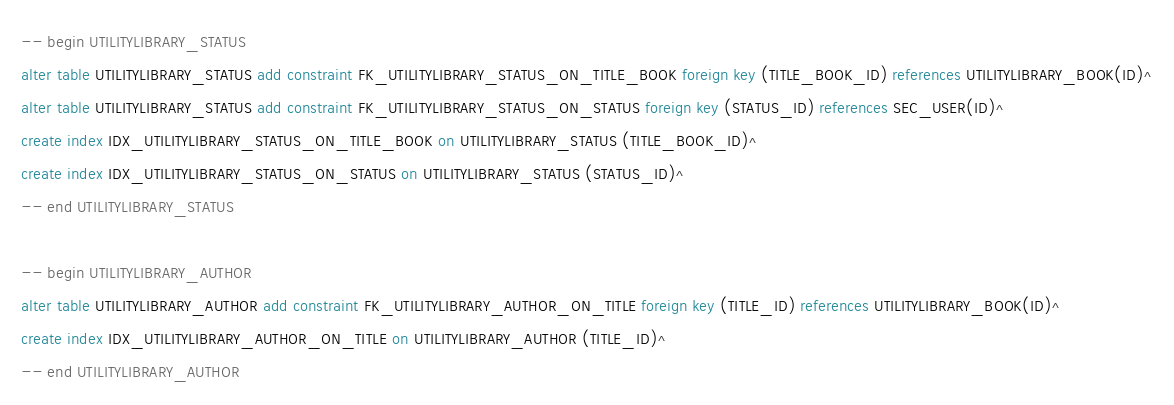Convert code to text. <code><loc_0><loc_0><loc_500><loc_500><_SQL_>-- begin UTILITYLIBRARY_STATUS
alter table UTILITYLIBRARY_STATUS add constraint FK_UTILITYLIBRARY_STATUS_ON_TITLE_BOOK foreign key (TITLE_BOOK_ID) references UTILITYLIBRARY_BOOK(ID)^
alter table UTILITYLIBRARY_STATUS add constraint FK_UTILITYLIBRARY_STATUS_ON_STATUS foreign key (STATUS_ID) references SEC_USER(ID)^
create index IDX_UTILITYLIBRARY_STATUS_ON_TITLE_BOOK on UTILITYLIBRARY_STATUS (TITLE_BOOK_ID)^
create index IDX_UTILITYLIBRARY_STATUS_ON_STATUS on UTILITYLIBRARY_STATUS (STATUS_ID)^
-- end UTILITYLIBRARY_STATUS

-- begin UTILITYLIBRARY_AUTHOR
alter table UTILITYLIBRARY_AUTHOR add constraint FK_UTILITYLIBRARY_AUTHOR_ON_TITLE foreign key (TITLE_ID) references UTILITYLIBRARY_BOOK(ID)^
create index IDX_UTILITYLIBRARY_AUTHOR_ON_TITLE on UTILITYLIBRARY_AUTHOR (TITLE_ID)^
-- end UTILITYLIBRARY_AUTHOR
</code> 